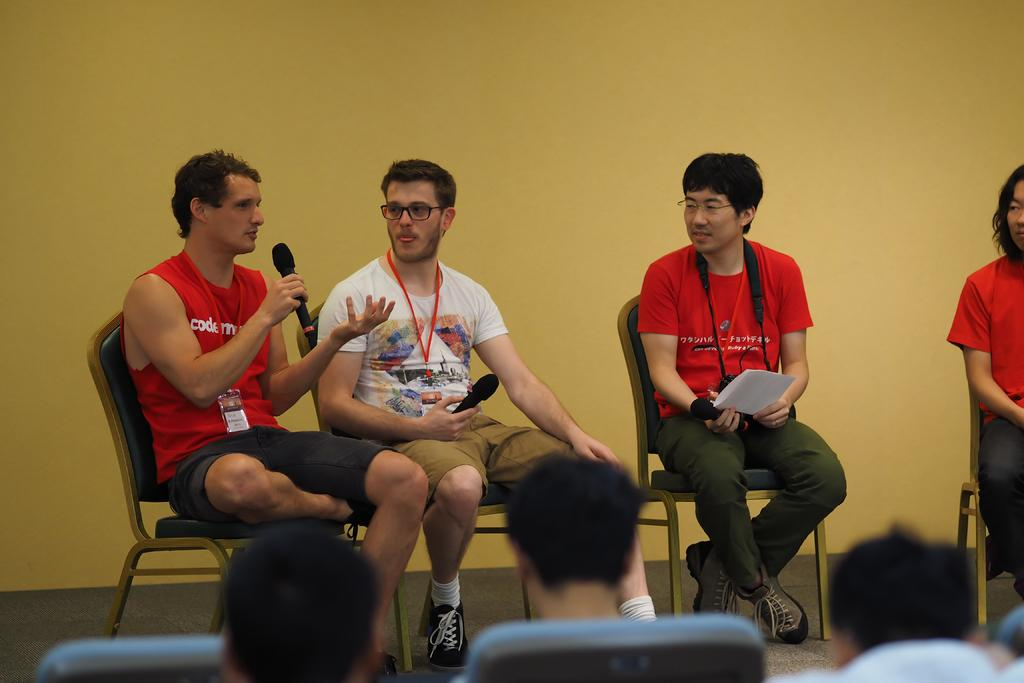What are the people in the image doing? The people in the image are sitting on chairs. What are some of the people holding in their hands? Some people are holding objects in their hands. How can you identify some of the people in the image? Some people are wearing ID cards. What can be seen in the background of the image? There is a wall in the background of the image. What type of jewel can be seen on the deer in the image? There is no deer or jewel present in the image. 